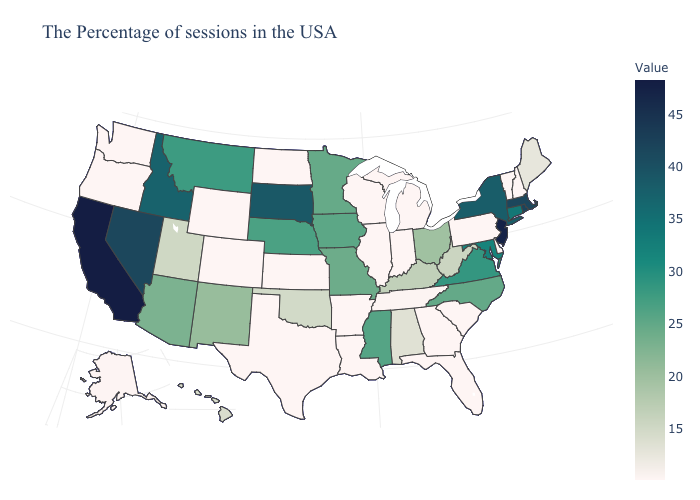Does Connecticut have the highest value in the USA?
Keep it brief. No. Which states hav the highest value in the Northeast?
Short answer required. New Jersey. Among the states that border Florida , which have the highest value?
Answer briefly. Alabama. Does Florida have the lowest value in the South?
Write a very short answer. Yes. 